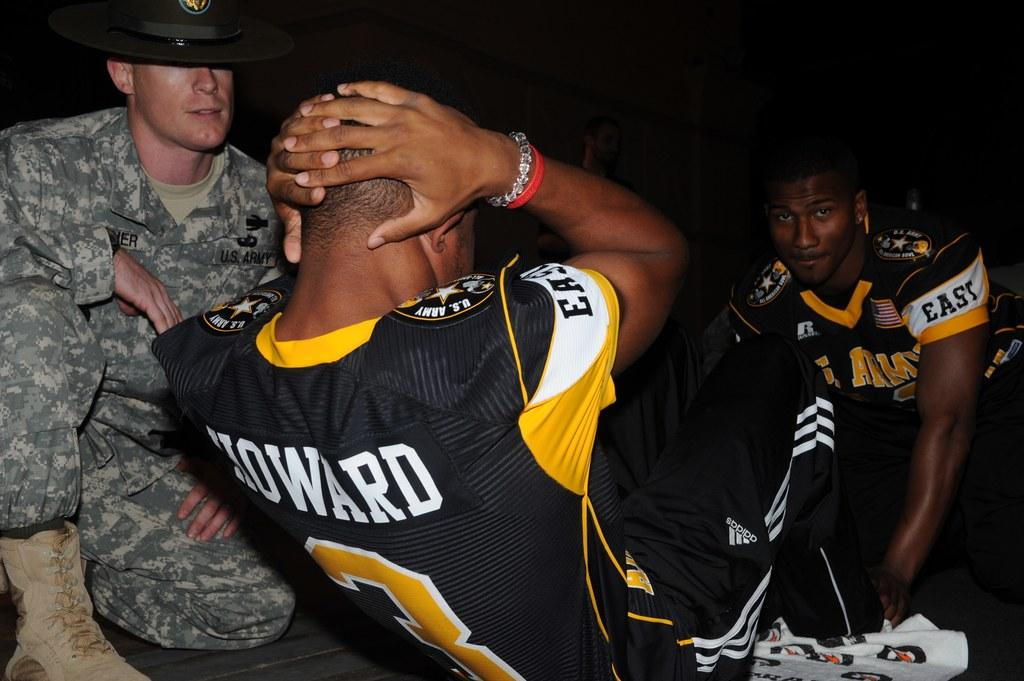<image>
Describe the image concisely. Football player Howard is doing situps with the help of a teammate while a man in a U.S. Army uniform watches. 